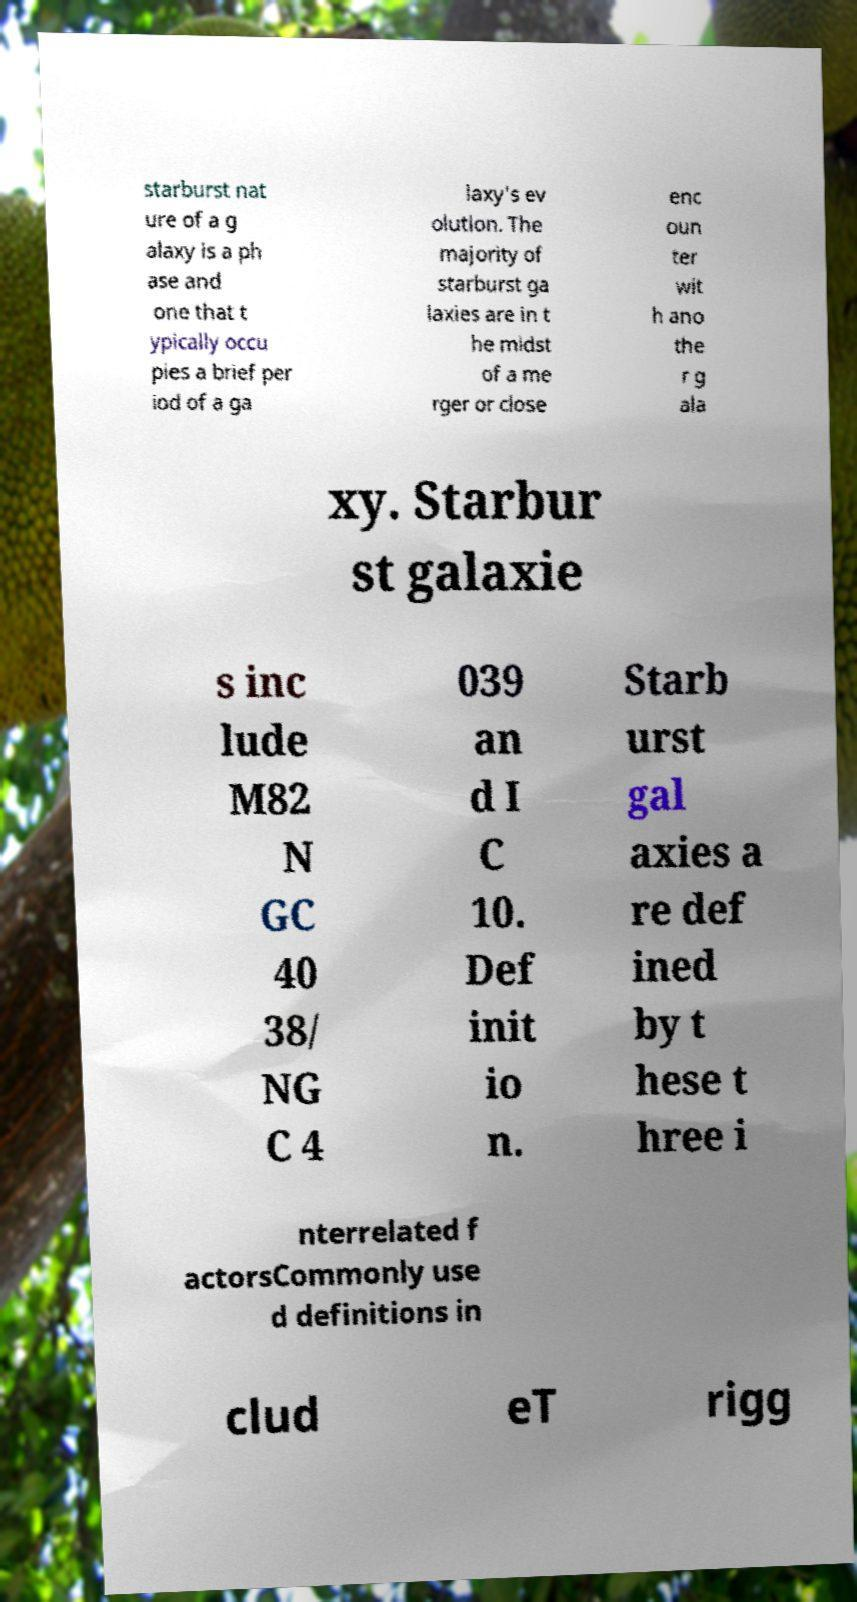I need the written content from this picture converted into text. Can you do that? starburst nat ure of a g alaxy is a ph ase and one that t ypically occu pies a brief per iod of a ga laxy's ev olution. The majority of starburst ga laxies are in t he midst of a me rger or close enc oun ter wit h ano the r g ala xy. Starbur st galaxie s inc lude M82 N GC 40 38/ NG C 4 039 an d I C 10. Def init io n. Starb urst gal axies a re def ined by t hese t hree i nterrelated f actorsCommonly use d definitions in clud eT rigg 